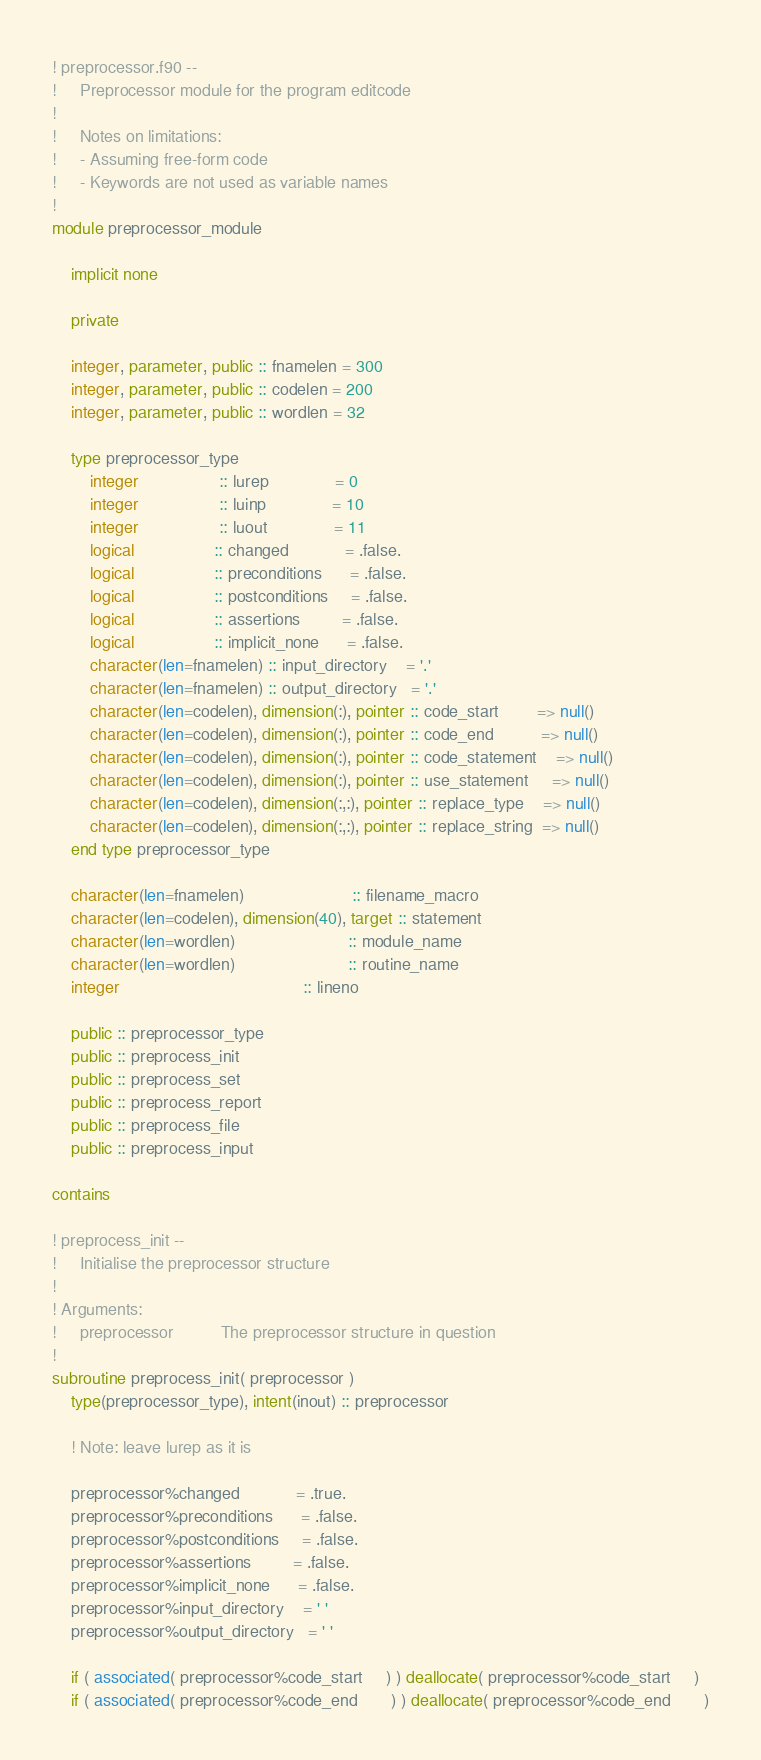Convert code to text. <code><loc_0><loc_0><loc_500><loc_500><_FORTRAN_>! preprocessor.f90 --
!     Preprocessor module for the program editcode
!
!     Notes on limitations:
!     - Assuming free-form code
!     - Keywords are not used as variable names
!
module preprocessor_module

    implicit none

    private

    integer, parameter, public :: fnamelen = 300
    integer, parameter, public :: codelen = 200
    integer, parameter, public :: wordlen = 32

    type preprocessor_type
        integer                 :: lurep              = 0
        integer                 :: luinp              = 10
        integer                 :: luout              = 11
        logical                 :: changed            = .false.
        logical                 :: preconditions      = .false.
        logical                 :: postconditions     = .false.
        logical                 :: assertions         = .false.
        logical                 :: implicit_none      = .false.
        character(len=fnamelen) :: input_directory    = '.'
        character(len=fnamelen) :: output_directory   = '.'
        character(len=codelen), dimension(:), pointer :: code_start        => null()
        character(len=codelen), dimension(:), pointer :: code_end          => null()
        character(len=codelen), dimension(:), pointer :: code_statement    => null()
        character(len=codelen), dimension(:), pointer :: use_statement     => null()
        character(len=codelen), dimension(:,:), pointer :: replace_type    => null()
        character(len=codelen), dimension(:,:), pointer :: replace_string  => null()
    end type preprocessor_type

    character(len=fnamelen)                       :: filename_macro
    character(len=codelen), dimension(40), target :: statement
    character(len=wordlen)                        :: module_name
    character(len=wordlen)                        :: routine_name
    integer                                       :: lineno

    public :: preprocessor_type
    public :: preprocess_init
    public :: preprocess_set
    public :: preprocess_report
    public :: preprocess_file
    public :: preprocess_input

contains

! preprocess_init --
!     Initialise the preprocessor structure
!
! Arguments:
!     preprocessor          The preprocessor structure in question
!
subroutine preprocess_init( preprocessor )
    type(preprocessor_type), intent(inout) :: preprocessor

    ! Note: leave lurep as it is

    preprocessor%changed            = .true.
    preprocessor%preconditions      = .false.
    preprocessor%postconditions     = .false.
    preprocessor%assertions         = .false.
    preprocessor%implicit_none      = .false.
    preprocessor%input_directory    = ' '
    preprocessor%output_directory   = ' '

    if ( associated( preprocessor%code_start     ) ) deallocate( preprocessor%code_start     )
    if ( associated( preprocessor%code_end       ) ) deallocate( preprocessor%code_end       )</code> 